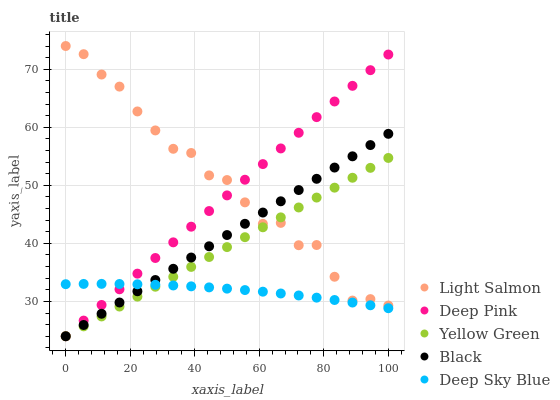Does Deep Sky Blue have the minimum area under the curve?
Answer yes or no. Yes. Does Light Salmon have the maximum area under the curve?
Answer yes or no. Yes. Does Deep Pink have the minimum area under the curve?
Answer yes or no. No. Does Deep Pink have the maximum area under the curve?
Answer yes or no. No. Is Deep Pink the smoothest?
Answer yes or no. Yes. Is Light Salmon the roughest?
Answer yes or no. Yes. Is Black the smoothest?
Answer yes or no. No. Is Black the roughest?
Answer yes or no. No. Does Deep Pink have the lowest value?
Answer yes or no. Yes. Does Deep Sky Blue have the lowest value?
Answer yes or no. No. Does Light Salmon have the highest value?
Answer yes or no. Yes. Does Deep Pink have the highest value?
Answer yes or no. No. Is Deep Sky Blue less than Light Salmon?
Answer yes or no. Yes. Is Light Salmon greater than Deep Sky Blue?
Answer yes or no. Yes. Does Deep Pink intersect Black?
Answer yes or no. Yes. Is Deep Pink less than Black?
Answer yes or no. No. Is Deep Pink greater than Black?
Answer yes or no. No. Does Deep Sky Blue intersect Light Salmon?
Answer yes or no. No. 